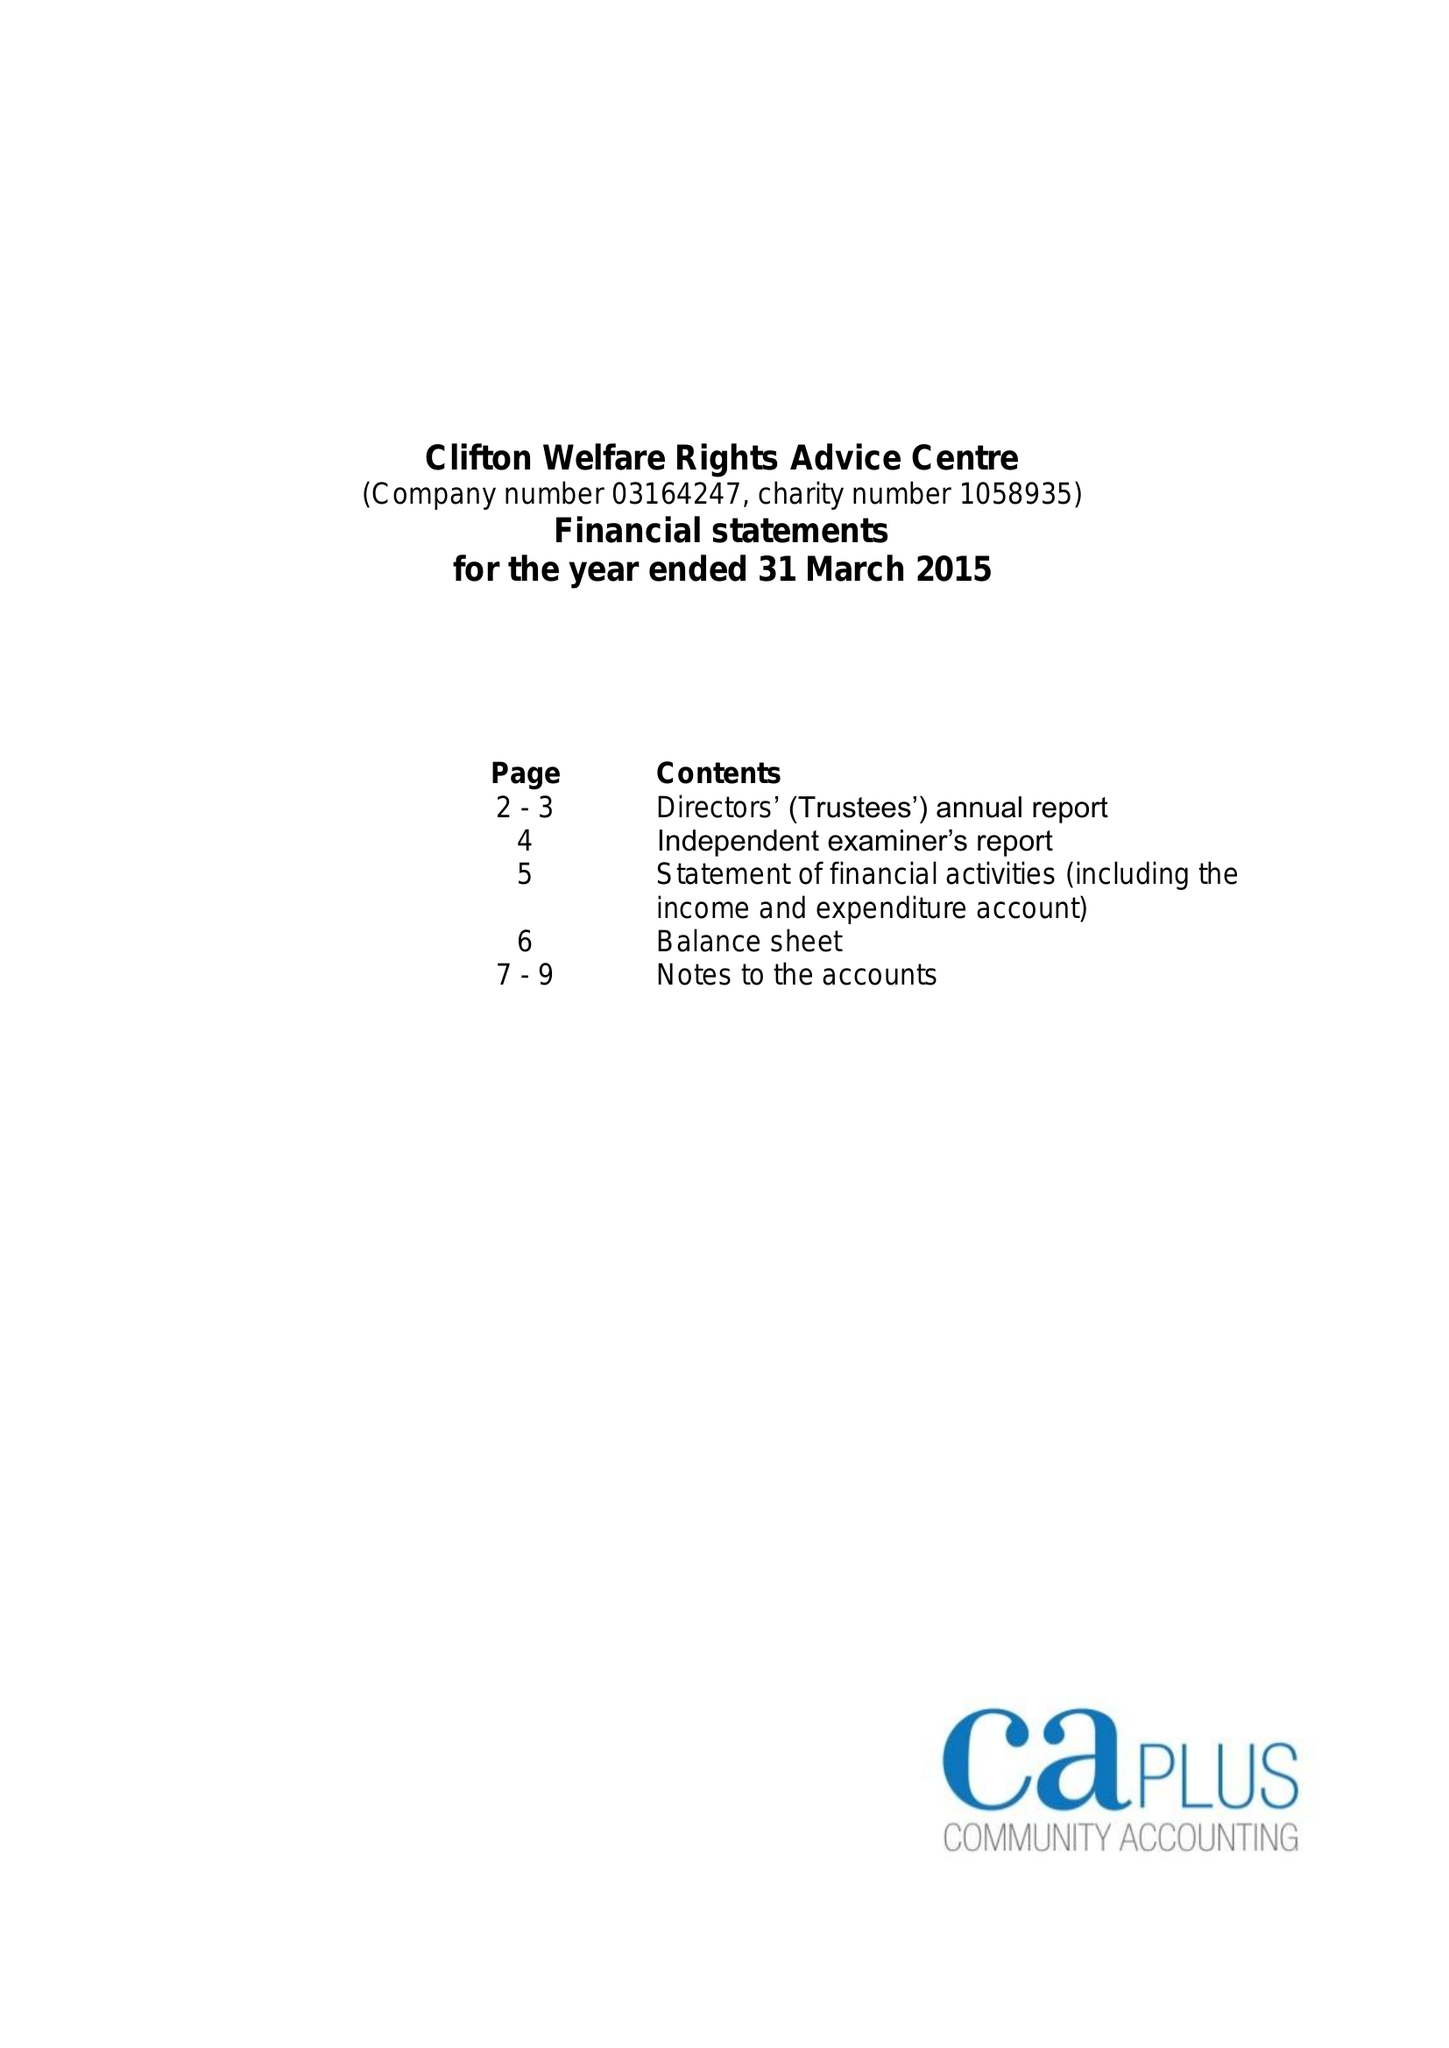What is the value for the address__post_town?
Answer the question using a single word or phrase. NOTTINGHAM 